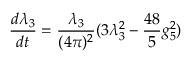<formula> <loc_0><loc_0><loc_500><loc_500>\frac { d \lambda _ { 3 } } { d t } = \frac { \lambda _ { 3 } } { ( 4 \pi ) ^ { 2 } } ( 3 \lambda _ { 3 } ^ { 2 } - \frac { 4 8 } { 5 } g _ { 5 } ^ { 2 } )</formula> 